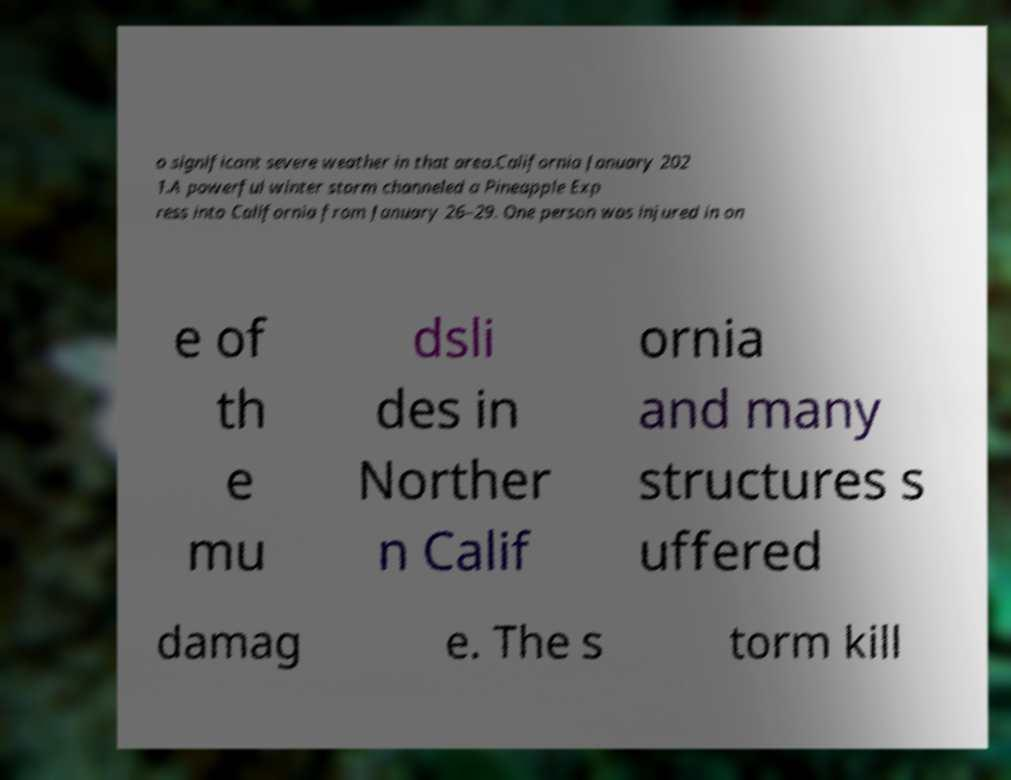Could you extract and type out the text from this image? o significant severe weather in that area.California January 202 1.A powerful winter storm channeled a Pineapple Exp ress into California from January 26–29. One person was injured in on e of th e mu dsli des in Norther n Calif ornia and many structures s uffered damag e. The s torm kill 